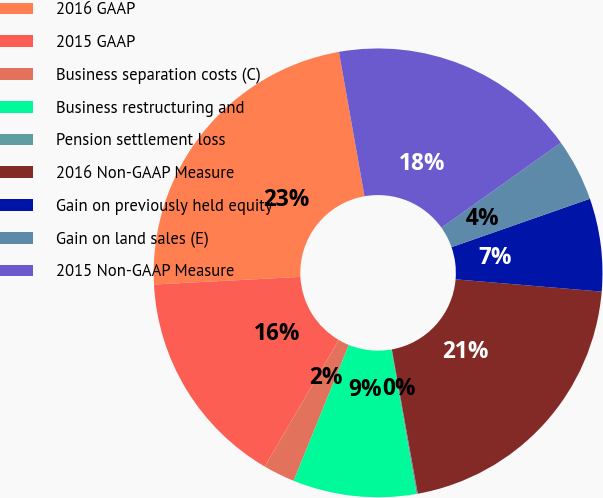Convert chart. <chart><loc_0><loc_0><loc_500><loc_500><pie_chart><fcel>2016 GAAP<fcel>2015 GAAP<fcel>Business separation costs (C)<fcel>Business restructuring and<fcel>Pension settlement loss<fcel>2016 Non-GAAP Measure<fcel>Gain on previously held equity<fcel>Gain on land sales (E)<fcel>2015 Non-GAAP Measure<nl><fcel>23.04%<fcel>15.75%<fcel>2.29%<fcel>8.88%<fcel>0.09%<fcel>20.84%<fcel>6.69%<fcel>4.49%<fcel>17.95%<nl></chart> 